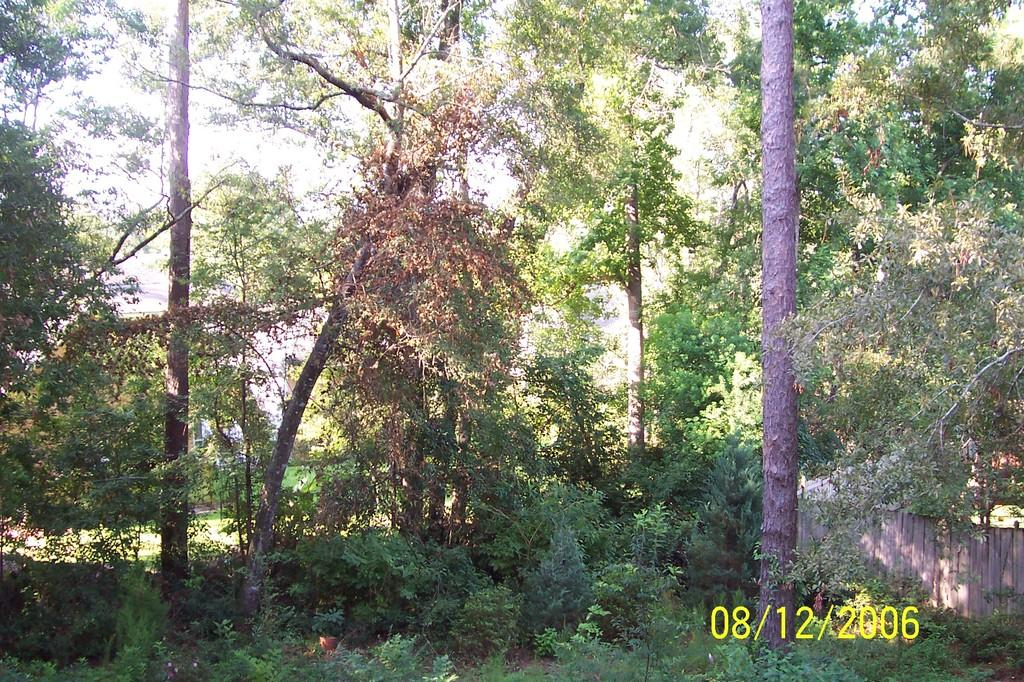What type of vegetation can be seen in the image? There are trees and plants in the image. What type of structure is present in the image? There is a wooden fence and a building in the image. What type of ship can be seen sailing in the image? There is no ship present in the image; it features trees, plants, a wooden fence, and a building. 